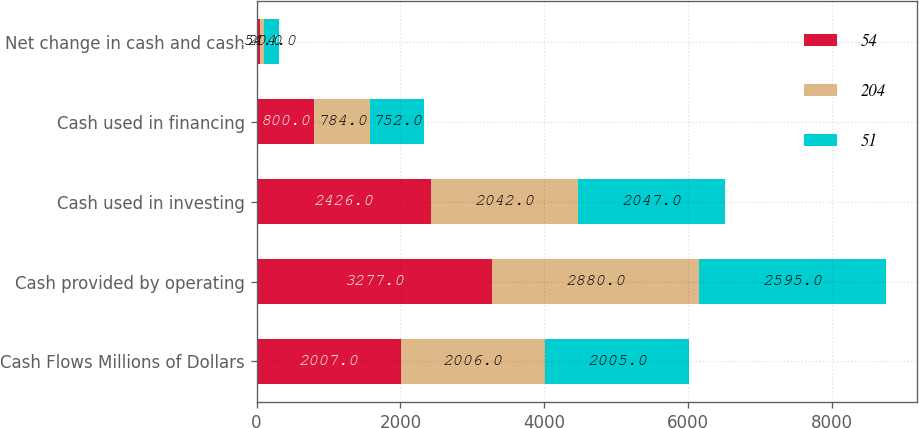<chart> <loc_0><loc_0><loc_500><loc_500><stacked_bar_chart><ecel><fcel>Cash Flows Millions of Dollars<fcel>Cash provided by operating<fcel>Cash used in investing<fcel>Cash used in financing<fcel>Net change in cash and cash<nl><fcel>54<fcel>2007<fcel>3277<fcel>2426<fcel>800<fcel>51<nl><fcel>204<fcel>2006<fcel>2880<fcel>2042<fcel>784<fcel>54<nl><fcel>51<fcel>2005<fcel>2595<fcel>2047<fcel>752<fcel>204<nl></chart> 